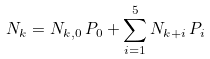<formula> <loc_0><loc_0><loc_500><loc_500>N _ { k } = N _ { k , 0 } \, P _ { 0 } + \sum _ { i = 1 } ^ { 5 } N _ { k + i } \, P _ { i }</formula> 